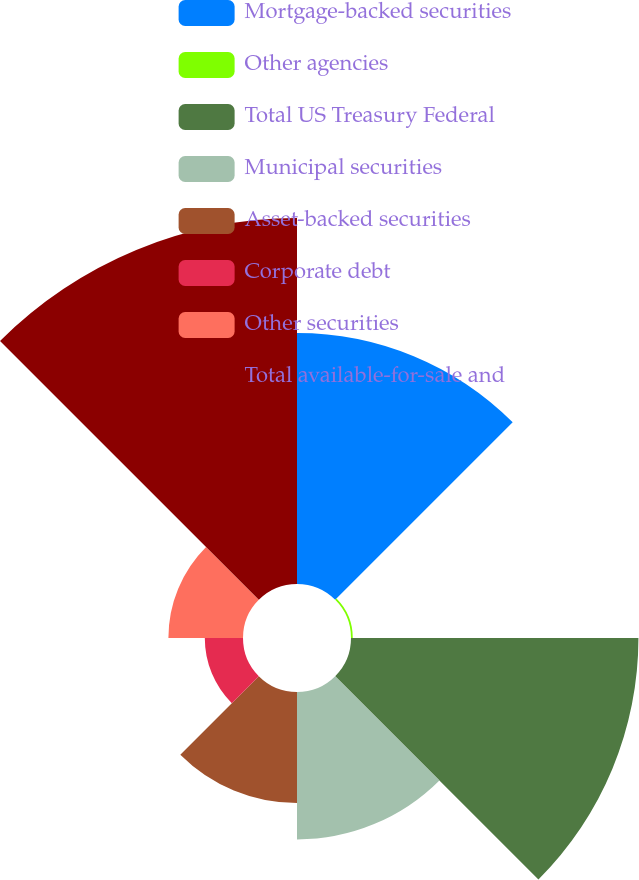<chart> <loc_0><loc_0><loc_500><loc_500><pie_chart><fcel>Mortgage-backed securities<fcel>Other agencies<fcel>Total US Treasury Federal<fcel>Municipal securities<fcel>Asset-backed securities<fcel>Corporate debt<fcel>Other securities<fcel>Total available-for-sale and<nl><fcel>19.65%<fcel>0.14%<fcel>22.5%<fcel>11.54%<fcel>8.69%<fcel>2.99%<fcel>5.84%<fcel>28.65%<nl></chart> 